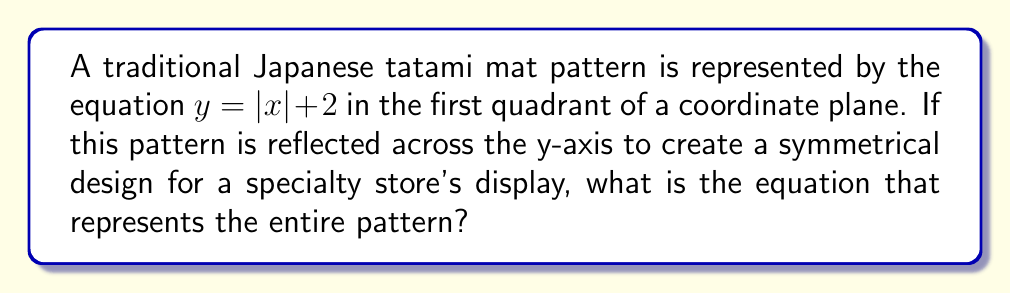Can you solve this math problem? Let's approach this step-by-step:

1) The original equation $y = |x| + 2$ represents the right half of the pattern in the first quadrant.

2) To create symmetry across the y-axis, we need to reflect this pattern.

3) Reflection across the y-axis changes x to -x in the equation.

4) However, we're dealing with an absolute value function. The absolute value of a negative number is positive, so $|-x| = |x|$.

5) This means that the reflected part will have the same equation as the original part.

6) Therefore, the equation $y = |x| + 2$ actually represents both the original and the reflected pattern.

7) To represent the entire pattern, we just need to extend the domain to include both positive and negative x values.

8) The complete equation that represents the symmetrical pattern for both positive and negative x values is $y = |x| + 2$, where $x \in \mathbb{R}$ (x is any real number).

[asy]
import graph;
size(200);
xaxis("x");
yaxis("y");

real f(real x) {return abs(x)+2;}
draw(graph(f,-4,4),blue);

label("$y=|x|+2$", (3,5), E);
[/asy]
Answer: $y = |x| + 2$, where $x \in \mathbb{R}$ 